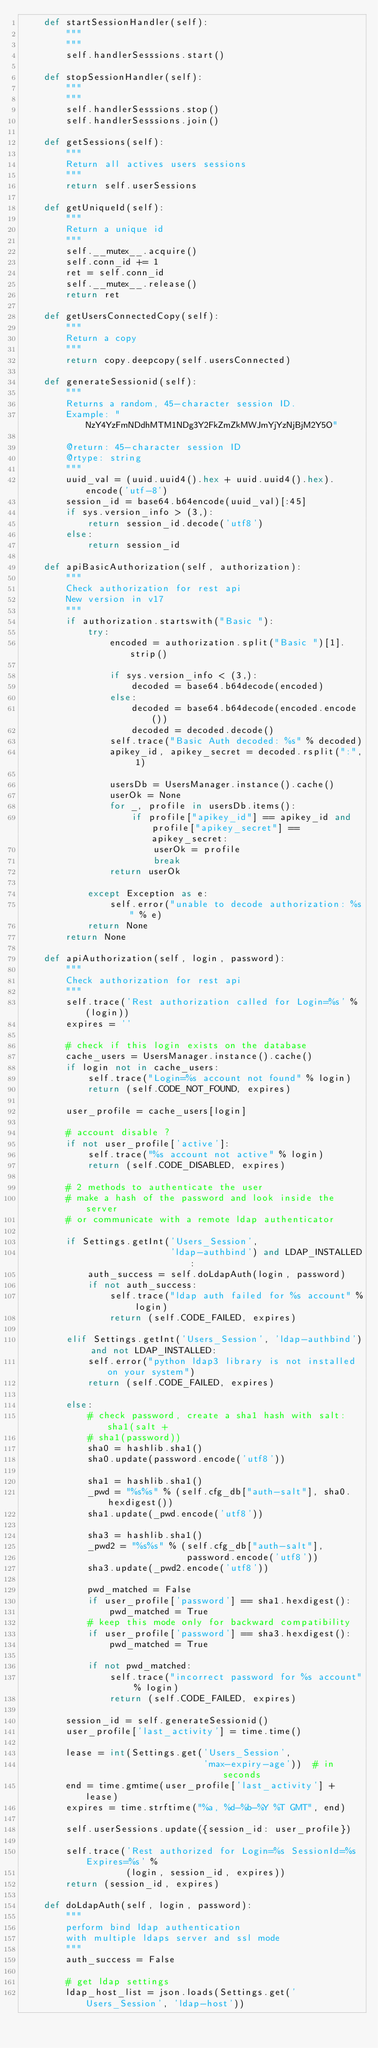Convert code to text. <code><loc_0><loc_0><loc_500><loc_500><_Python_>    def startSessionHandler(self):
        """
        """
        self.handlerSesssions.start()

    def stopSessionHandler(self):
        """
        """
        self.handlerSesssions.stop()
        self.handlerSesssions.join()

    def getSessions(self):
        """
        Return all actives users sessions
        """
        return self.userSessions

    def getUniqueId(self):
        """
        Return a unique id
        """
        self.__mutex__.acquire()
        self.conn_id += 1
        ret = self.conn_id
        self.__mutex__.release()
        return ret

    def getUsersConnectedCopy(self):
        """
        Return a copy
        """
        return copy.deepcopy(self.usersConnected)

    def generateSessionid(self):
        """
        Returns a random, 45-character session ID.
        Example: "NzY4YzFmNDdhMTM1NDg3Y2FkZmZkMWJmYjYzNjBjM2Y5O"

        @return: 45-character session ID
        @rtype: string
        """
        uuid_val = (uuid.uuid4().hex + uuid.uuid4().hex).encode('utf-8')
        session_id = base64.b64encode(uuid_val)[:45]
        if sys.version_info > (3,):
            return session_id.decode('utf8')
        else:
            return session_id

    def apiBasicAuthorization(self, authorization):
        """
        Check authorization for rest api
        New version in v17
        """
        if authorization.startswith("Basic "):
            try:
                encoded = authorization.split("Basic ")[1].strip()

                if sys.version_info < (3,):
                    decoded = base64.b64decode(encoded)
                else:
                    decoded = base64.b64decode(encoded.encode())
                    decoded = decoded.decode()
                self.trace("Basic Auth decoded: %s" % decoded)
                apikey_id, apikey_secret = decoded.rsplit(":", 1)

                usersDb = UsersManager.instance().cache()
                userOk = None
                for _, profile in usersDb.items():
                    if profile["apikey_id"] == apikey_id and profile["apikey_secret"] == apikey_secret:
                        userOk = profile
                        break
                return userOk

            except Exception as e:
                self.error("unable to decode authorization: %s" % e)
            return None
        return None

    def apiAuthorization(self, login, password):
        """
        Check authorization for rest api
        """
        self.trace('Rest authorization called for Login=%s' % (login))
        expires = ''

        # check if this login exists on the database
        cache_users = UsersManager.instance().cache()
        if login not in cache_users:
            self.trace("Login=%s account not found" % login)
            return (self.CODE_NOT_FOUND, expires)

        user_profile = cache_users[login]

        # account disable ?
        if not user_profile['active']:
            self.trace("%s account not active" % login)
            return (self.CODE_DISABLED, expires)

        # 2 methods to authenticate the user
        # make a hash of the password and look inside the server
        # or communicate with a remote ldap authenticator

        if Settings.getInt('Users_Session',
                           'ldap-authbind') and LDAP_INSTALLED:
            auth_success = self.doLdapAuth(login, password)
            if not auth_success:
                self.trace("ldap auth failed for %s account" % login)
                return (self.CODE_FAILED, expires)

        elif Settings.getInt('Users_Session', 'ldap-authbind') and not LDAP_INSTALLED:
            self.error("python ldap3 library is not installed on your system")
            return (self.CODE_FAILED, expires)

        else:
            # check password, create a sha1 hash with salt: sha1(salt +
            # sha1(password))
            sha0 = hashlib.sha1()
            sha0.update(password.encode('utf8'))

            sha1 = hashlib.sha1()
            _pwd = "%s%s" % (self.cfg_db["auth-salt"], sha0.hexdigest())
            sha1.update(_pwd.encode('utf8'))

            sha3 = hashlib.sha1()
            _pwd2 = "%s%s" % (self.cfg_db["auth-salt"],
                              password.encode('utf8'))
            sha3.update(_pwd2.encode('utf8'))

            pwd_matched = False
            if user_profile['password'] == sha1.hexdigest():
                pwd_matched = True
            # keep this mode only for backward compatibility
            if user_profile['password'] == sha3.hexdigest():
                pwd_matched = True

            if not pwd_matched:
                self.trace("incorrect password for %s account" % login)
                return (self.CODE_FAILED, expires)

        session_id = self.generateSessionid()
        user_profile['last_activity'] = time.time()

        lease = int(Settings.get('Users_Session',
                                 'max-expiry-age'))  # in seconds
        end = time.gmtime(user_profile['last_activity'] + lease)
        expires = time.strftime("%a, %d-%b-%Y %T GMT", end)

        self.userSessions.update({session_id: user_profile})

        self.trace('Rest authorized for Login=%s SessionId=%s Expires=%s' %
                   (login, session_id, expires))
        return (session_id, expires)

    def doLdapAuth(self, login, password):
        """
        perform bind ldap authentication
        with multiple ldaps server and ssl mode
        """
        auth_success = False

        # get ldap settings
        ldap_host_list = json.loads(Settings.get('Users_Session', 'ldap-host'))</code> 